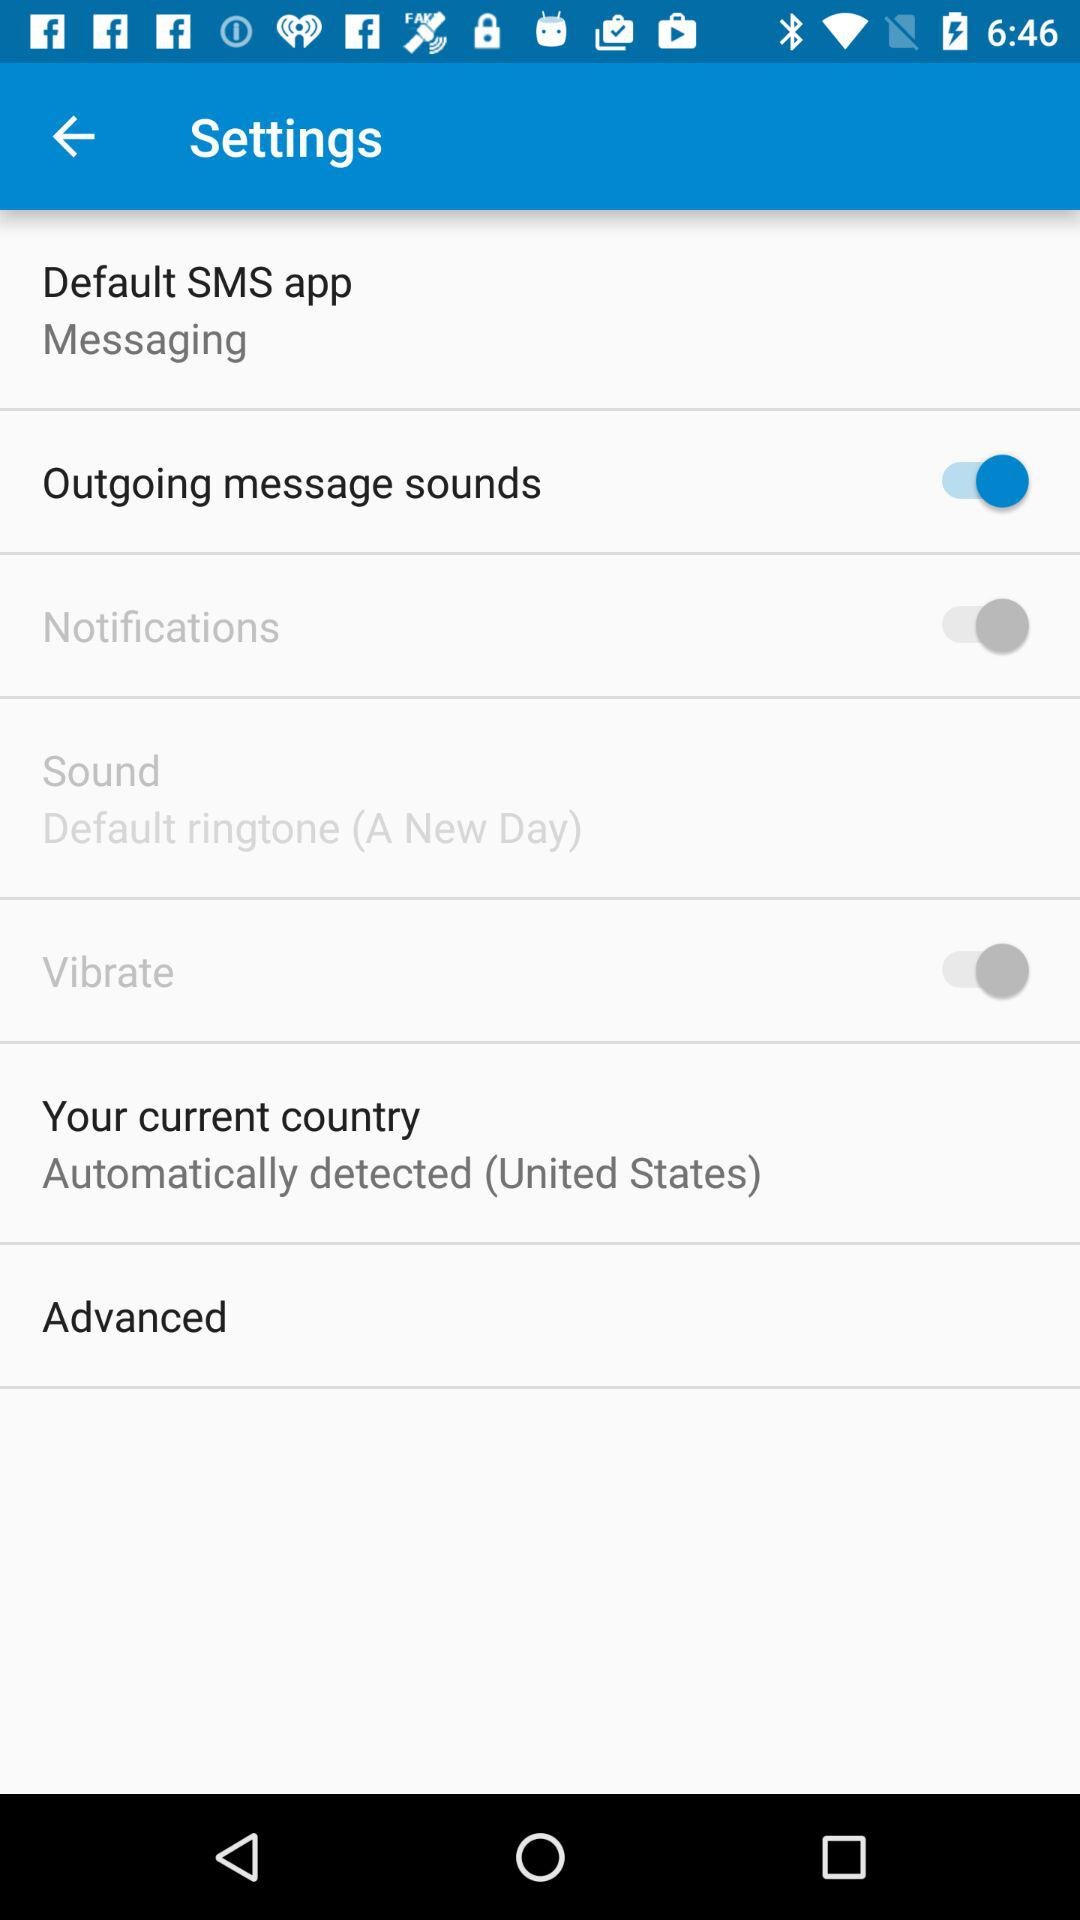What is the setting for notifications? The setting is "on". 